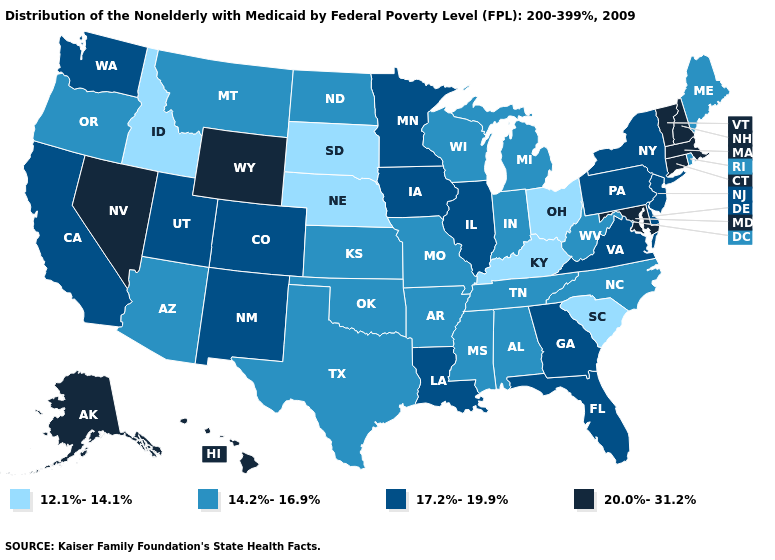Name the states that have a value in the range 12.1%-14.1%?
Write a very short answer. Idaho, Kentucky, Nebraska, Ohio, South Carolina, South Dakota. What is the lowest value in the South?
Short answer required. 12.1%-14.1%. Name the states that have a value in the range 14.2%-16.9%?
Keep it brief. Alabama, Arizona, Arkansas, Indiana, Kansas, Maine, Michigan, Mississippi, Missouri, Montana, North Carolina, North Dakota, Oklahoma, Oregon, Rhode Island, Tennessee, Texas, West Virginia, Wisconsin. Does the first symbol in the legend represent the smallest category?
Answer briefly. Yes. Which states have the highest value in the USA?
Quick response, please. Alaska, Connecticut, Hawaii, Maryland, Massachusetts, Nevada, New Hampshire, Vermont, Wyoming. Does the first symbol in the legend represent the smallest category?
Give a very brief answer. Yes. What is the lowest value in the USA?
Concise answer only. 12.1%-14.1%. What is the highest value in states that border Utah?
Concise answer only. 20.0%-31.2%. Name the states that have a value in the range 12.1%-14.1%?
Short answer required. Idaho, Kentucky, Nebraska, Ohio, South Carolina, South Dakota. Is the legend a continuous bar?
Keep it brief. No. What is the lowest value in states that border Arkansas?
Be succinct. 14.2%-16.9%. What is the value of Oregon?
Short answer required. 14.2%-16.9%. Name the states that have a value in the range 12.1%-14.1%?
Give a very brief answer. Idaho, Kentucky, Nebraska, Ohio, South Carolina, South Dakota. Does South Carolina have the lowest value in the South?
Keep it brief. Yes. 